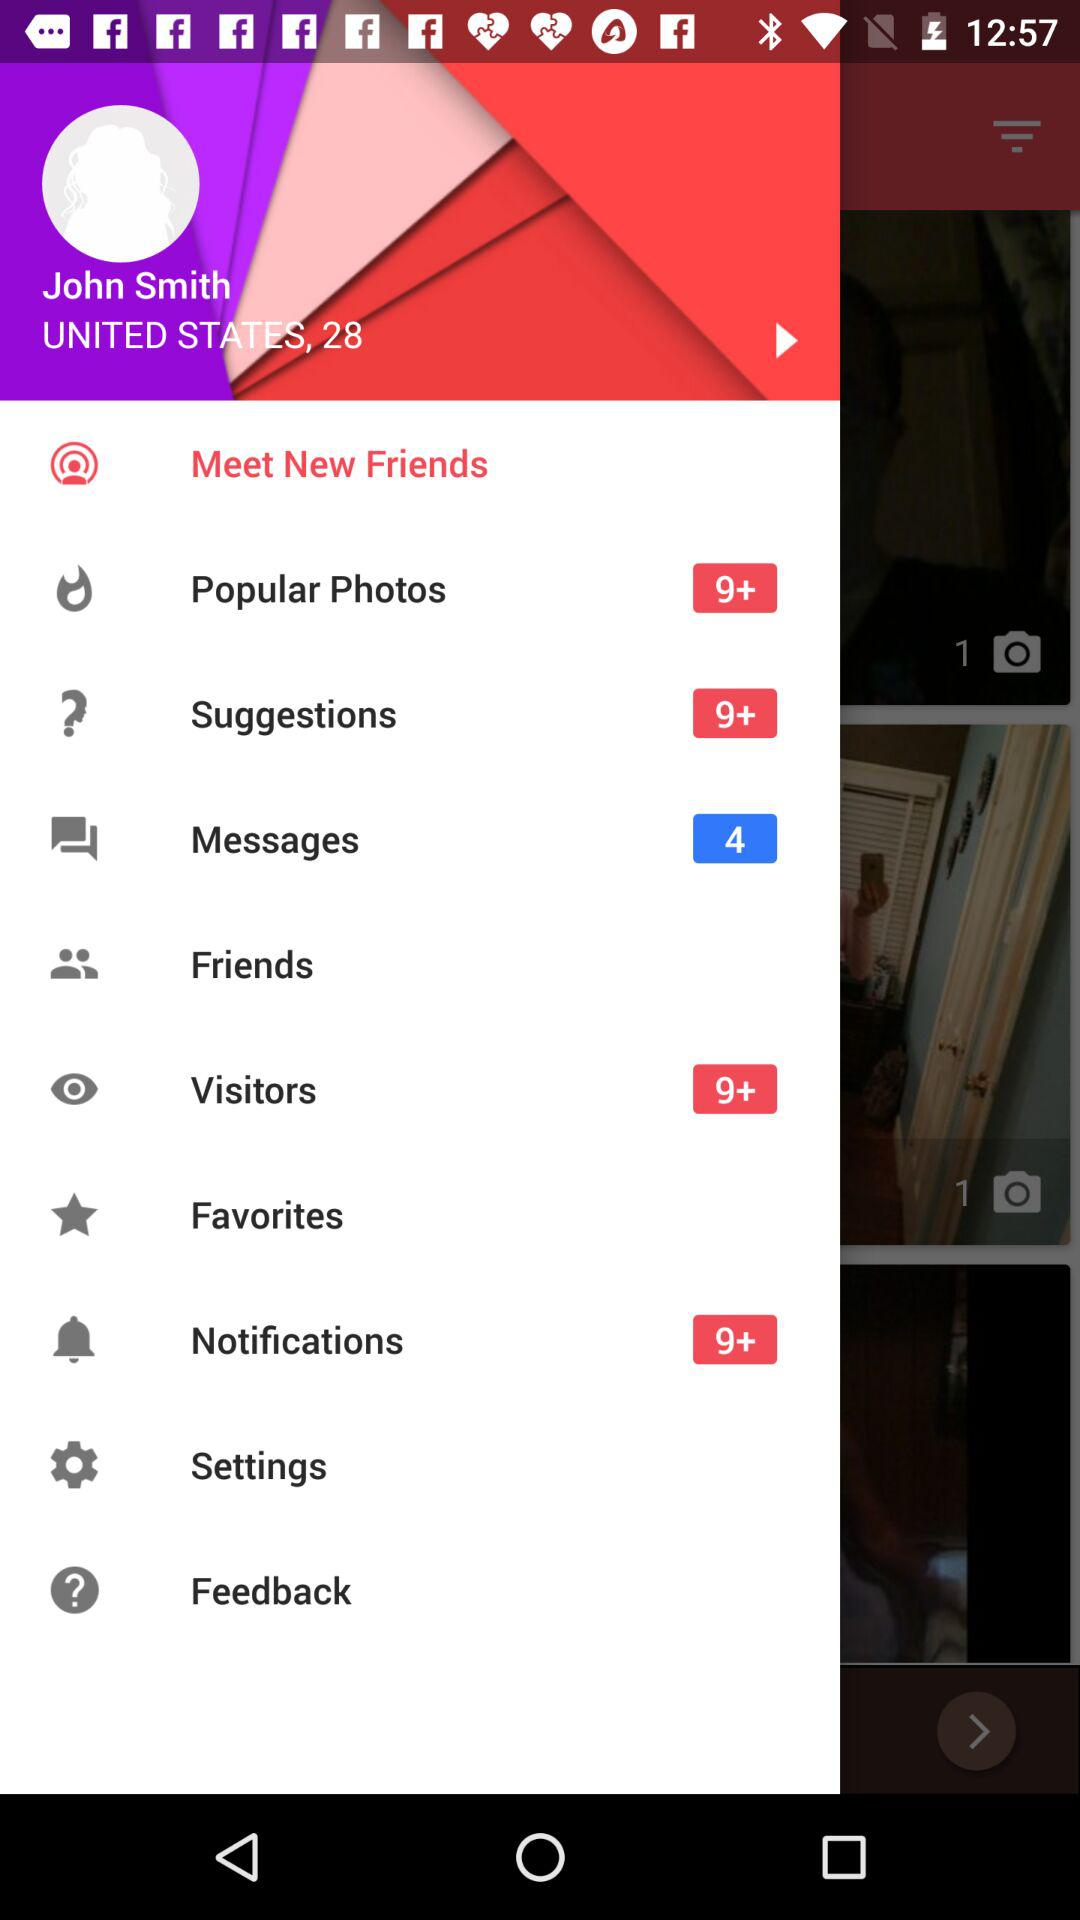What is the user name? The user name is John Smith. 